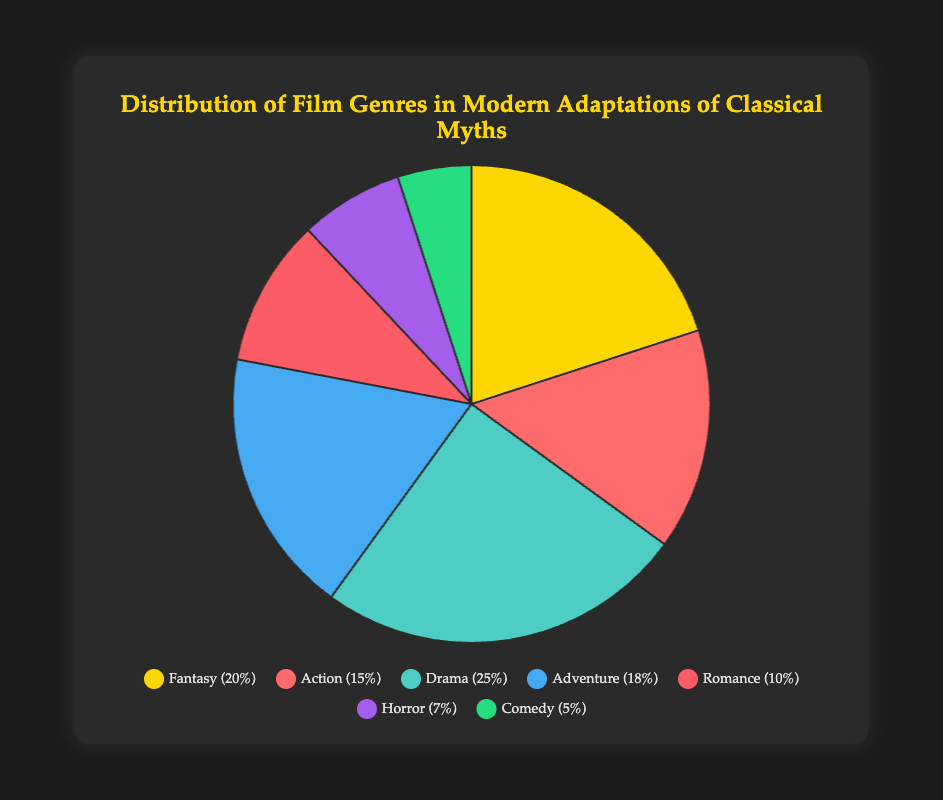What's the most common genre in modern adaptations of classical myths? The pie chart shows that Drama occupies the largest segment compared to other genres with a percentage of 25%. Hence, Drama is the most common genre.
Answer: Drama Which two genres together make up more than 50% of the films? Adding the percentages of the two largest segments, Drama (25%) and Fantasy (20%), we get 45%. Adding the next largest, Adventure (18%), Drama and Fantasy make up 50% of the chart segments, thus, Drama (25%) and Fantasy (20%) together make up 45%, so we need to consider Adventure too.
Answer: Drama and Fantasy Which genre is represented by the red segment? The pie chart shows different colors representing different genres. The red segment corresponds to Action, as per the visual legend.
Answer: Action Which genres have almost the same percentage representation, with only a 3% difference between them? To find the genres with only a 3% difference, we compare the values. Fantasy (20%) and Adventure (18%) differ by only 2%, while Drama (25%) and Adventure (18%) differ by 7%, etc. Thus, Fantasy and Adventure have nearly the same percentage with a difference of only 2%.
Answer: Fantasy and Adventure What is the percentage difference between the least common genre and the most common genre? The least common genre is Comedy with 5% and the most common genre is Drama with 25%. The percentage difference is calculated as 25% - 5% = 20%.
Answer: 20% How many genres have a percentage lower than 10%? From the data, Romance (10%), Horror (7%), and Comedy (5%) are checked. Romance (10%) is equal to but not lower. Only Horror and Comedy (2 in total) have percentages lower than 10%.
Answer: 2 What's the sum percentage of all the less common genres (less than 10%)? Adding up the percentages of less common genres: Horror (7%) and Comedy (5%), results in 7% + 5% = 12%.
Answer: 12% Can you identify an example film that falls under the Fantasy genre? The data provided lists "Clash of the Titans" and "Percy Jackson & the Olympians: The Lightning Thief" as examples under the Fantasy genre.
Answer: Clash of the Titans Which genre's segment is displayed in purple on the chart? The segment of the chart shown in purple corresponds to Horror, as per the legend's color indications.
Answer: Horror 